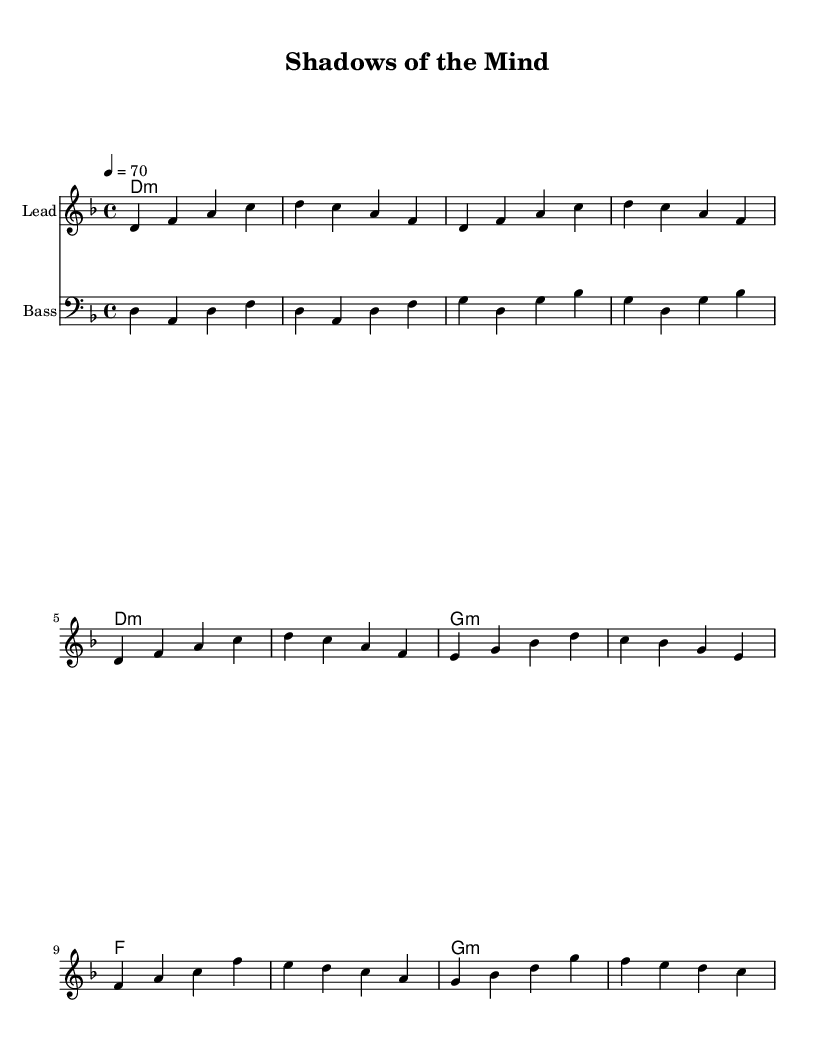What is the key signature of this music? The key signature is two flats, which indicates D minor. The presence of B flat accounts for the flat notes in the key signature.
Answer: D minor What is the time signature of this piece? The time signature is 4/4, meaning there are four beats in each measure and a quarter note gets one beat. This is often indicated at the beginning of the score.
Answer: 4/4 What is the tempo marking indicated in this sheet music? The tempo marking is a quarter note equals seventy beats per minute, which indicates the speed of the music. This is usually found at the beginning of the score.
Answer: 70 How many measures make up the intro section? The intro section consists of four measures, as seen in the first four lines of the melody. Each measure's separation indicates different musical phrases.
Answer: 4 What is the mode of the harmonies used in this piece? The harmonies are primarily in a minor mode, specifically indicating each chord's minor quality. This can be identified by the lowercase "m" next to the chord names.
Answer: Minor Which instrument plays the bassline? The bassline is designated for the bass instrument, indicated by the clef and the naming in the staff header. This is commonly denoted as "Bass."
Answer: Bass What is the structure of the music based on the segments? The structure of this music follows an intro, a verse, and a chorus, which is typical in song compositions. This can be deduced by looking at the labeled sections in the melody lines.
Answer: Intro, Verse, Chorus 